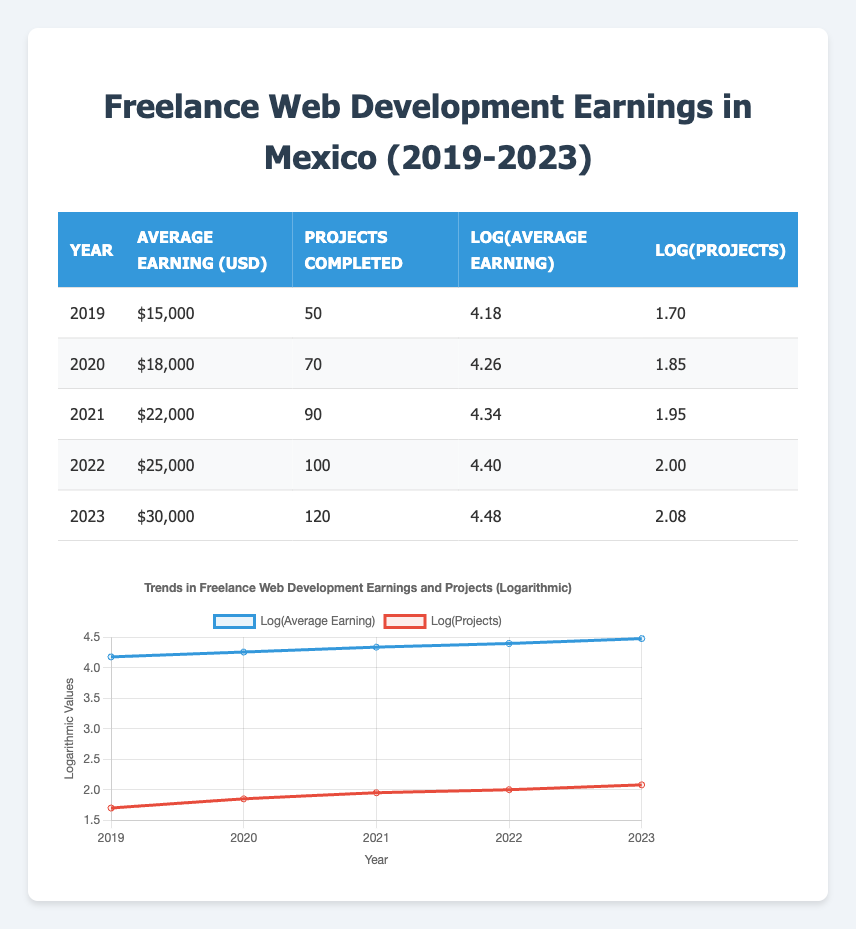What was the average earning in 2021? The table shows that in 2021, the average earning was $22,000.
Answer: 22000 How many projects were completed in 2020? Referring to the table, the number of projects completed in 2020 was 70.
Answer: 70 What year had the highest average earning? Looking at the table, the year with the highest average earning is 2023, with $30,000.
Answer: 2023 What was the increase in average earnings from 2019 to 2022? The average earning in 2019 was $15,000, and in 2022 it was $25,000. The increase is $25,000 - $15,000 = $10,000.
Answer: 10000 True or False: The average earning in 2020 was greater than $19,000. The average earning in 2020 is $18,000, which is less than $19,000, so the statement is false.
Answer: False What is the average number of projects completed over the five years? The total projects completed over five years are 50 + 70 + 90 + 100 + 120 = 430. The average over 5 years is 430 / 5 = 86.
Answer: 86 Is the logarithmic value of the average earning in 2023 greater than that in 2020? The logarithmic value of the average earning in 2023 is 4.48, while in 2020, it is 4.26. Since 4.48 is greater than 4.26, the statement is true.
Answer: True What is the total number of projects completed from 2019 to 2023? Summing the projects completed over the years: 50 + 70 + 90 + 100 + 120 = 430 gives a total of 430 projects completed.
Answer: 430 What was the increase in the logarithmic value of average earnings from 2019 to 2023? The logarithmic value in 2019 is 4.18, and in 2023 it is 4.48. The increase is 4.48 - 4.18 = 0.30.
Answer: 0.30 What was the average earning in 2022? According to the table, the average earning in 2022 was $25,000.
Answer: 25000 